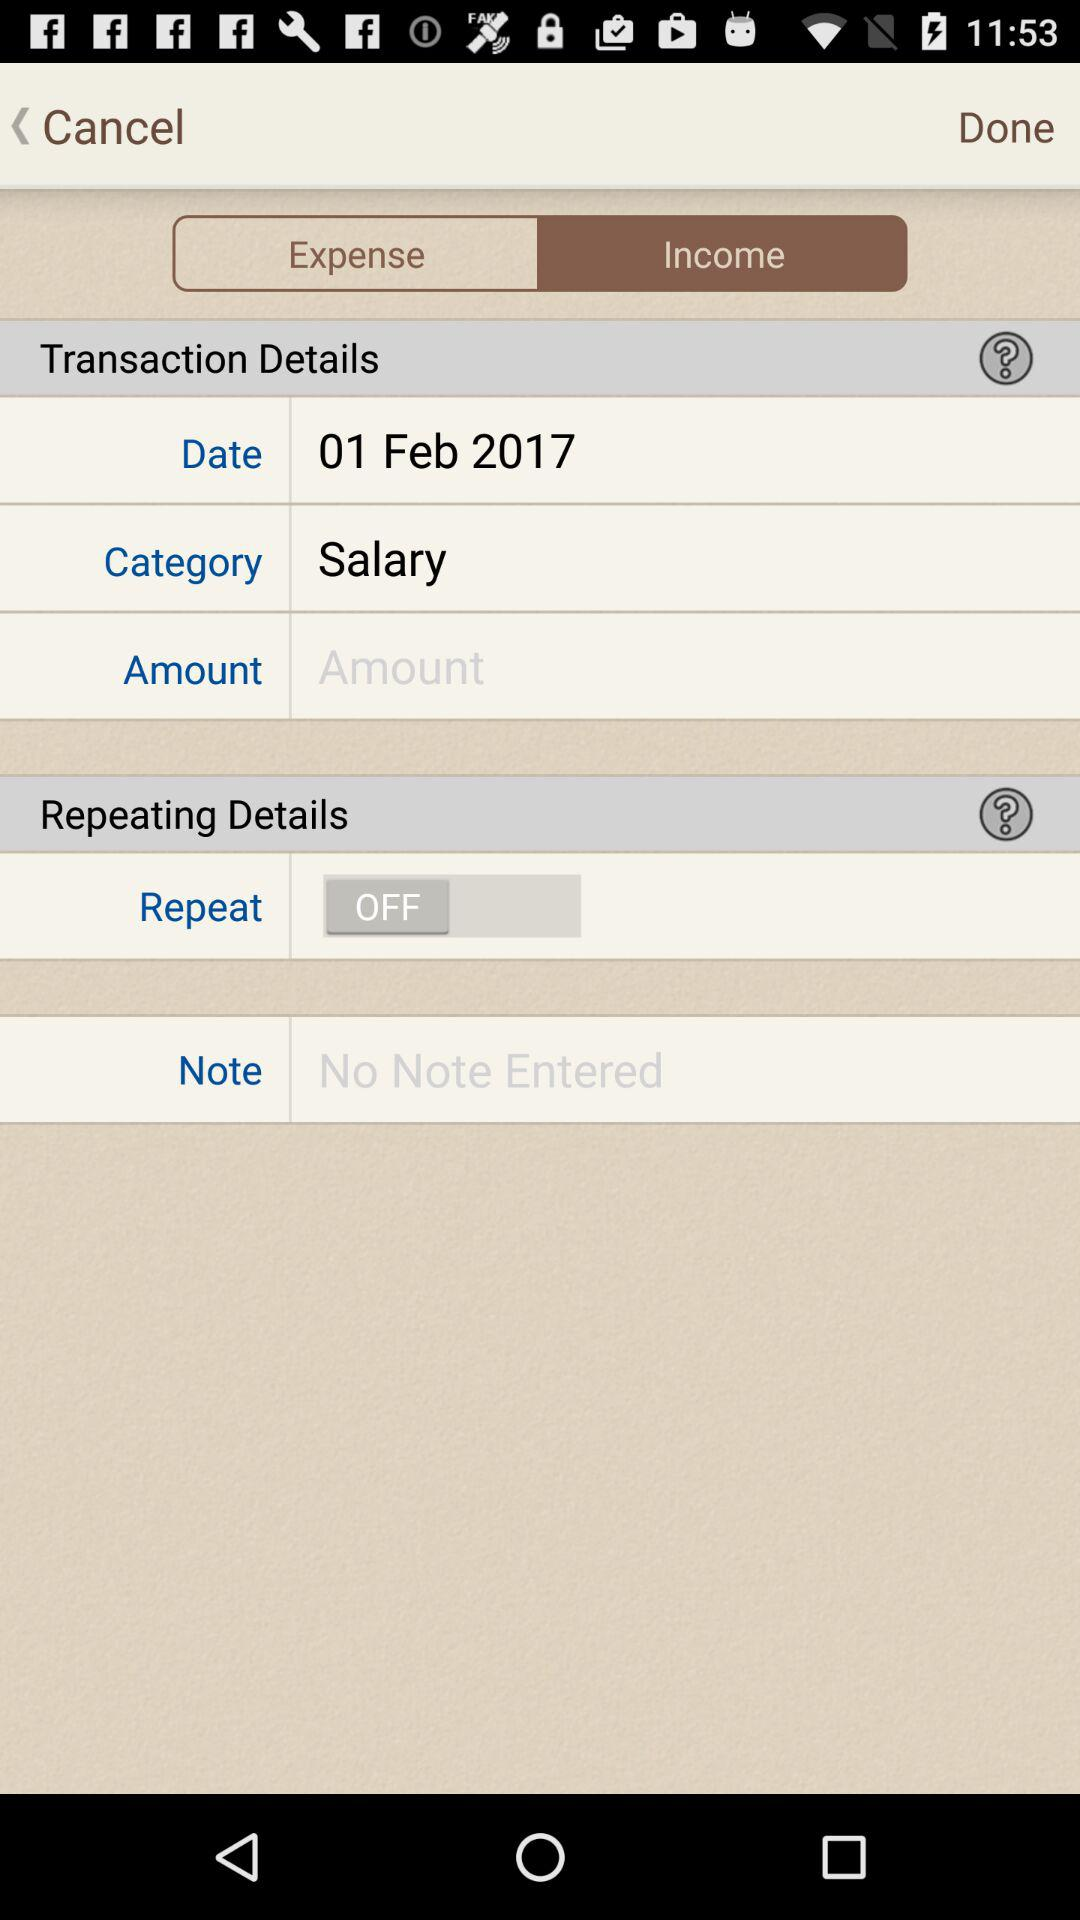What is the status of "Repeat"?
Answer the question using a single word or phrase. "Repeat" is off. 